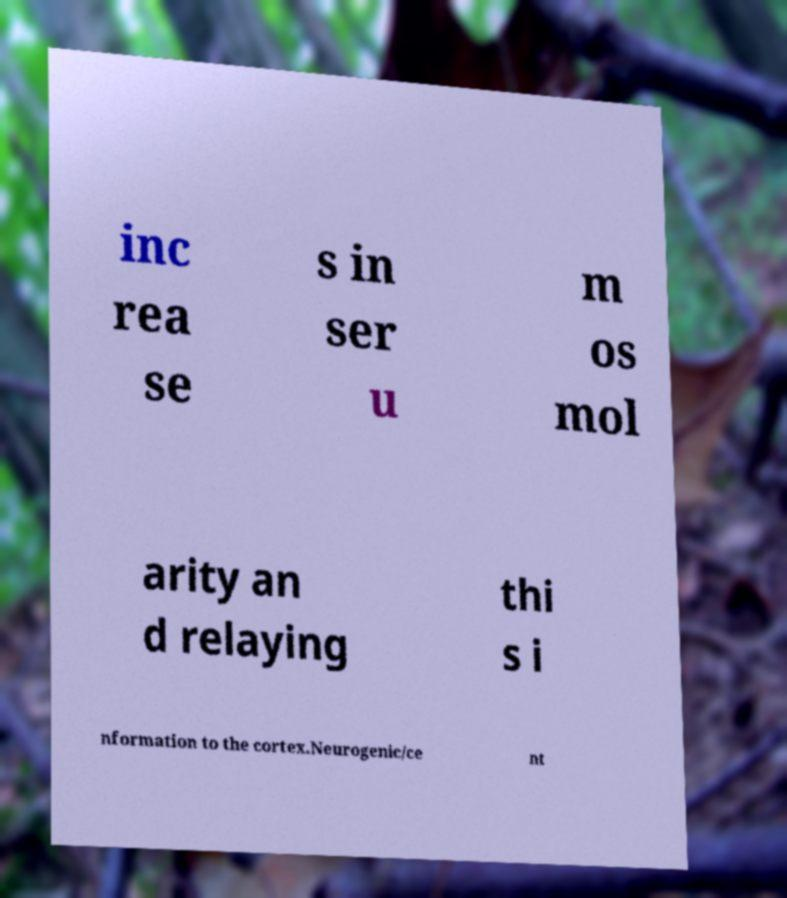I need the written content from this picture converted into text. Can you do that? inc rea se s in ser u m os mol arity an d relaying thi s i nformation to the cortex.Neurogenic/ce nt 